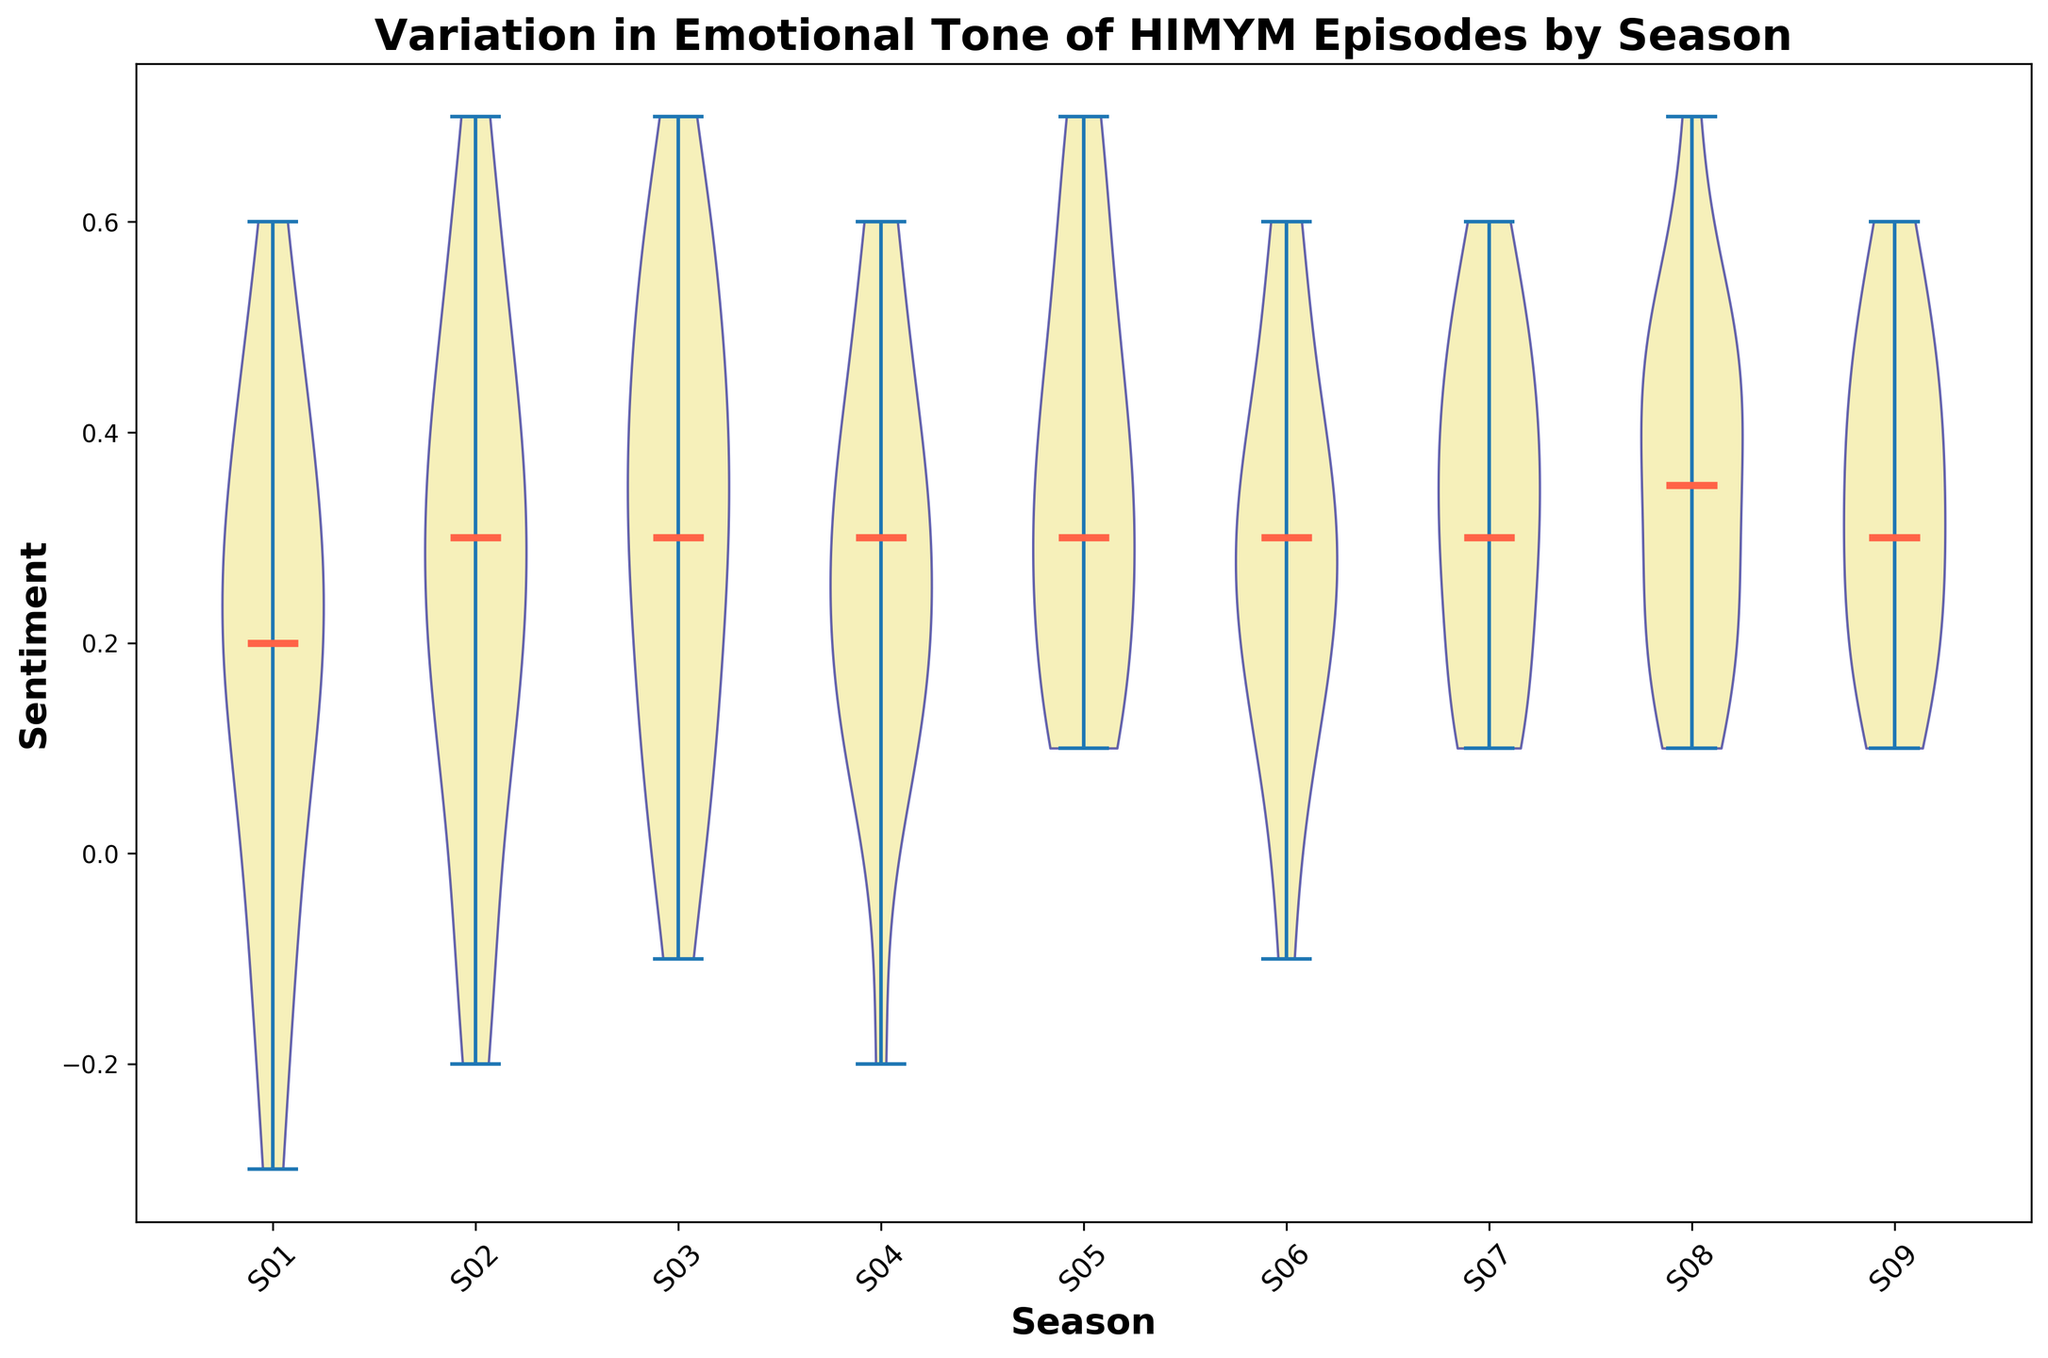Which season has the highest median sentiment? To determine this, look at the median lines in each violin plot and compare their positions. The higher the line, the higher the median sentiment. The median is the line running horizontally within each violin.
Answer: Season 8 Which season shows the smallest variation in sentiment? The variation can be identified by comparing the width of the violins. The narrower the violin, the smaller the variation.
Answer: Season 2 Are there any seasons with negative sentiments? Check if any violins extend below the x-axis (the sentiment of zero), indicating at least some negative sentiment values.
Answer: Yes (Season 1) Which season has the most consistent positive sentiment across episodes? Consistency in positive sentiment can be seen where the central region of the violin (interquartile range) is consistently above zero.
Answer: Season 6 What is the median sentiment value for Season 1? The median sentiment value is indicated by the dashed line for Season 1's violin plot.
Answer: 0.2 Compare the median sentiment of Season 5 and Season 7. Which one is higher? Compare the positions of the median lines of the violins for Season 5 and Season 7. The higher line corresponds to the higher median sentiment.
Answer: Season 7 How does the variation in sentiment in Season 4 compare to Season 9? Compare the width of the violins. Wider violins indicate higher variations in sentiment, so the season with the wider violin plot has more variation.
Answer: Season 4 has more variation Which season has the lowest median sentiment value? By observing the median lines of all seasons’ violins, identify the one that is positioned the lowest.
Answer: Season 1 Identify the season with the closest sentiment range around zero. Look for the violin plot where the sentiment values are densely packed around the zero line.
Answer: Season 2 How does the sentiment distribution of Season 3 compare to Season 8? Compare the shapes of the violin plots: width, height, and position of median lines. Season 3 has a broader range and slightly lower median compared to the high and less variable sentiment in Season 8.
Answer: Season 3 has a broader range and lower median 